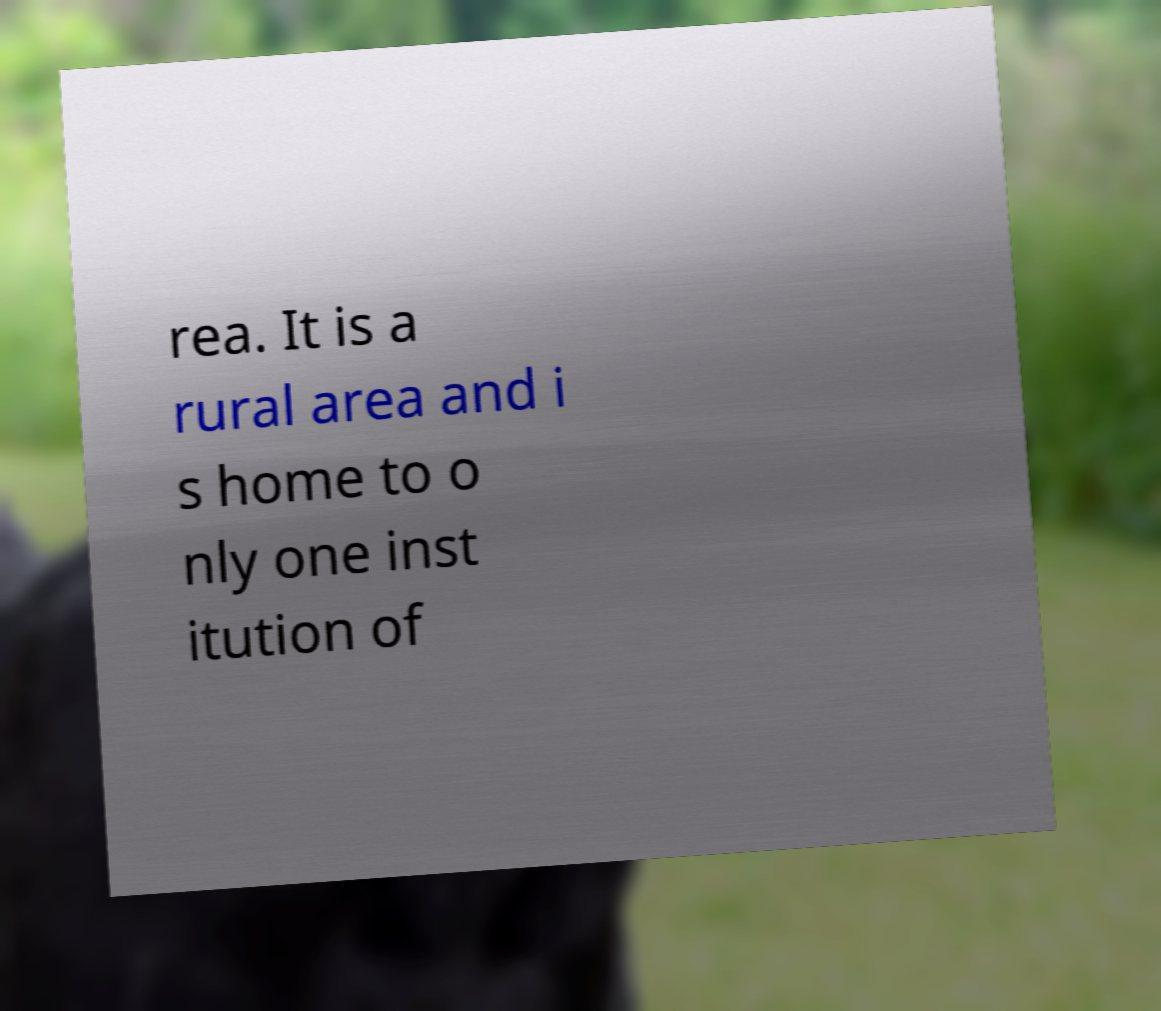Could you assist in decoding the text presented in this image and type it out clearly? rea. It is a rural area and i s home to o nly one inst itution of 